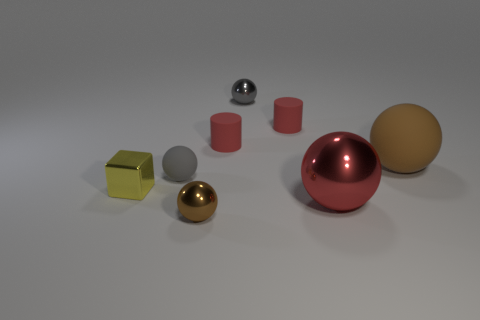Is there anything else that is the same size as the metallic cube? Yes, the smaller gray sphere appears to be roughly the same size as the metallic cube. 